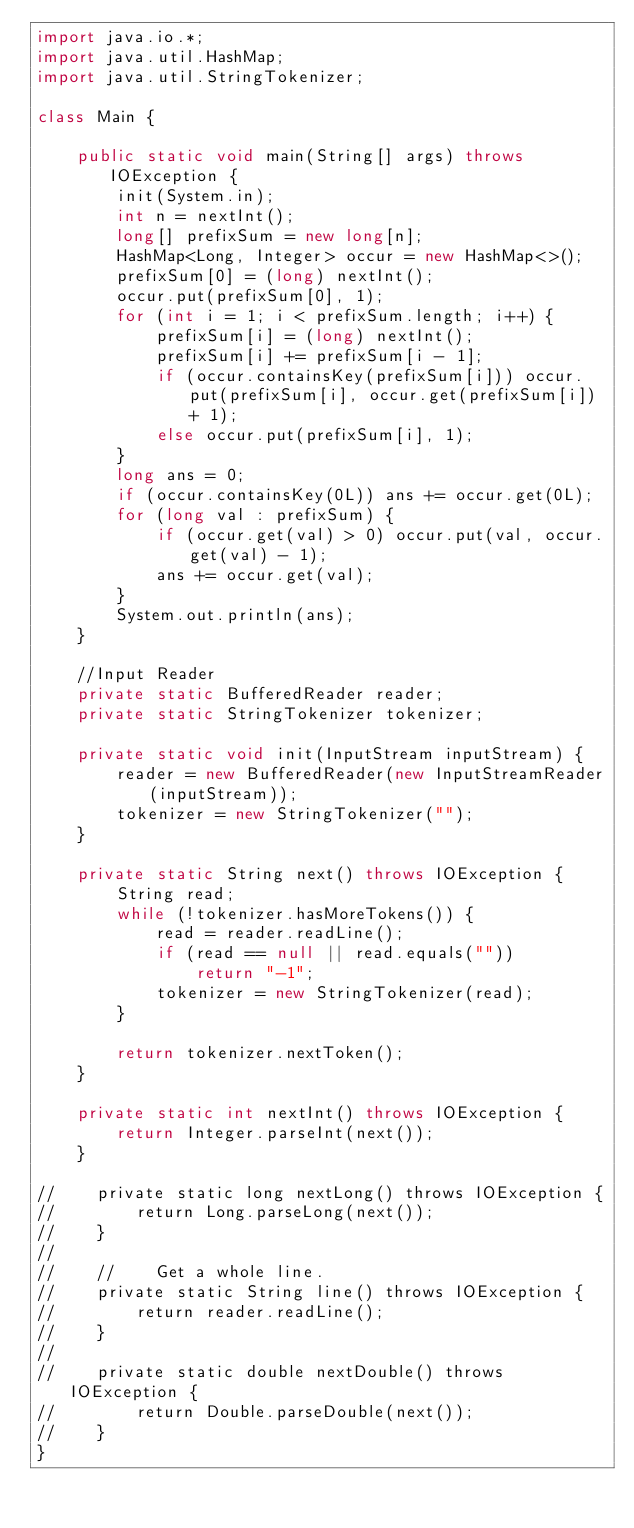Convert code to text. <code><loc_0><loc_0><loc_500><loc_500><_Java_>import java.io.*;
import java.util.HashMap;
import java.util.StringTokenizer;

class Main {

    public static void main(String[] args) throws IOException {
        init(System.in);
        int n = nextInt();
        long[] prefixSum = new long[n];
        HashMap<Long, Integer> occur = new HashMap<>();
        prefixSum[0] = (long) nextInt();
        occur.put(prefixSum[0], 1);
        for (int i = 1; i < prefixSum.length; i++) {
            prefixSum[i] = (long) nextInt();
            prefixSum[i] += prefixSum[i - 1];
            if (occur.containsKey(prefixSum[i])) occur.put(prefixSum[i], occur.get(prefixSum[i]) + 1);
            else occur.put(prefixSum[i], 1);
        }
        long ans = 0;
        if (occur.containsKey(0L)) ans += occur.get(0L);
        for (long val : prefixSum) {
            if (occur.get(val) > 0) occur.put(val, occur.get(val) - 1);
            ans += occur.get(val);
        }
        System.out.println(ans);
    }

    //Input Reader
    private static BufferedReader reader;
    private static StringTokenizer tokenizer;

    private static void init(InputStream inputStream) {
        reader = new BufferedReader(new InputStreamReader(inputStream));
        tokenizer = new StringTokenizer("");
    }

    private static String next() throws IOException {
        String read;
        while (!tokenizer.hasMoreTokens()) {
            read = reader.readLine();
            if (read == null || read.equals(""))
                return "-1";
            tokenizer = new StringTokenizer(read);
        }

        return tokenizer.nextToken();
    }

    private static int nextInt() throws IOException {
        return Integer.parseInt(next());
    }

//    private static long nextLong() throws IOException {
//        return Long.parseLong(next());
//    }
//
//    //    Get a whole line.
//    private static String line() throws IOException {
//        return reader.readLine();
//    }
//
//    private static double nextDouble() throws IOException {
//        return Double.parseDouble(next());
//    }
}

</code> 